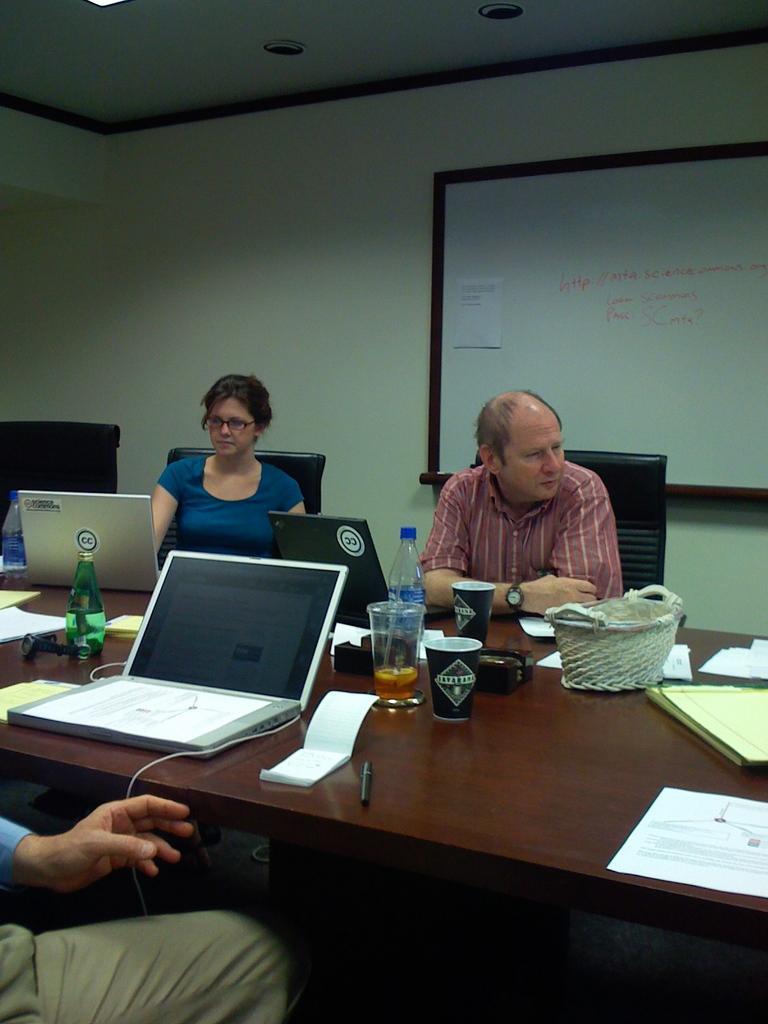Could you give a brief overview of what you see in this image? These persons are sitting on the chairs. We can see laptops,bottles,cup,glass,book,papers,pen,basket on the table. On the background we can see wall,whiteboard. On the top we can see lights. 